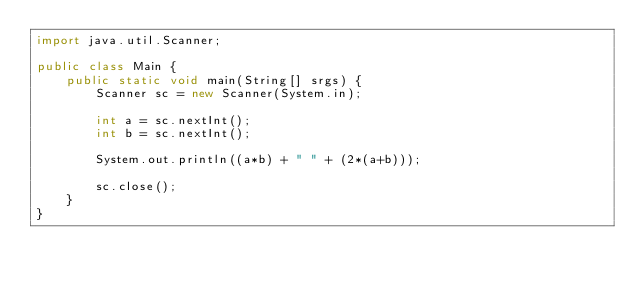<code> <loc_0><loc_0><loc_500><loc_500><_Java_>import java.util.Scanner;

public class Main {
    public static void main(String[] srgs) {
        Scanner sc = new Scanner(System.in);

        int a = sc.nextInt();
        int b = sc.nextInt();

        System.out.println((a*b) + " " + (2*(a+b)));

        sc.close();
    }
}
</code> 